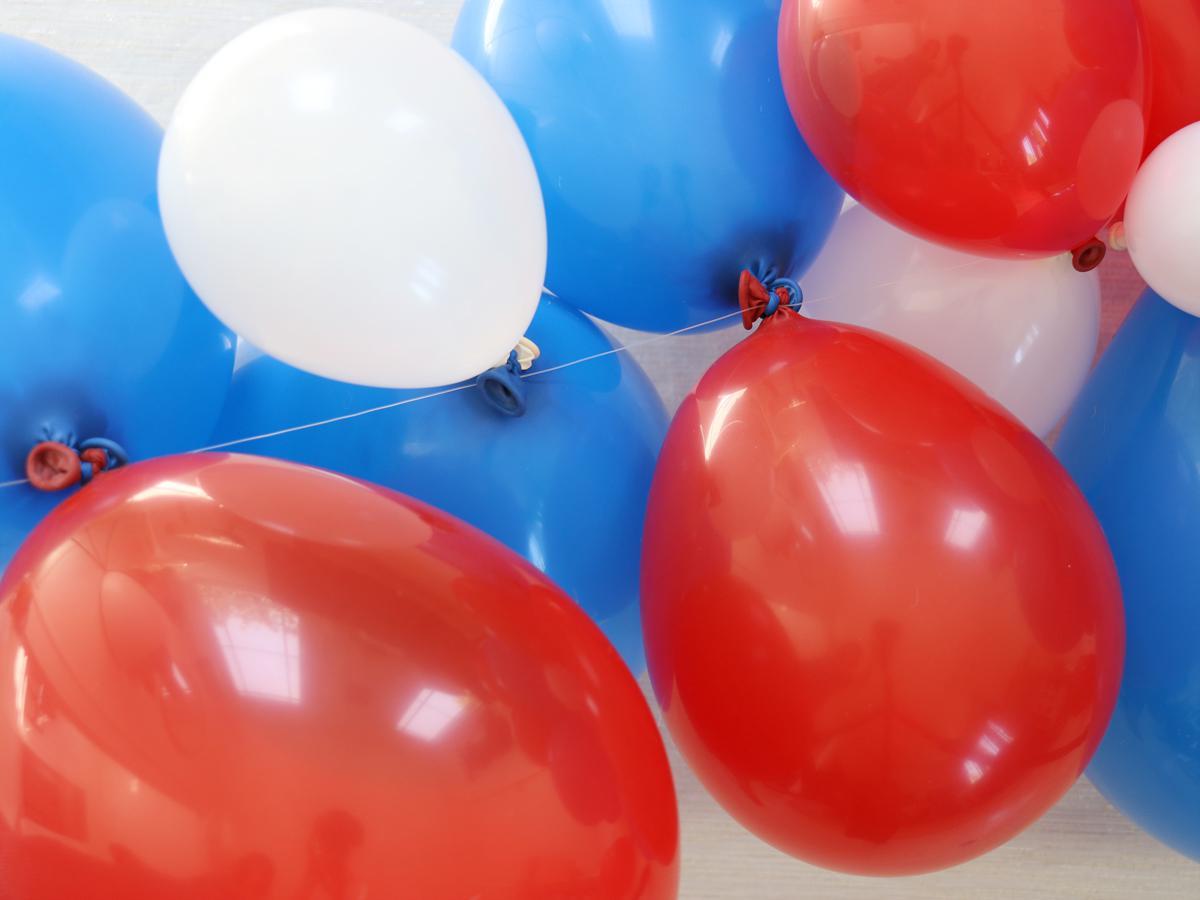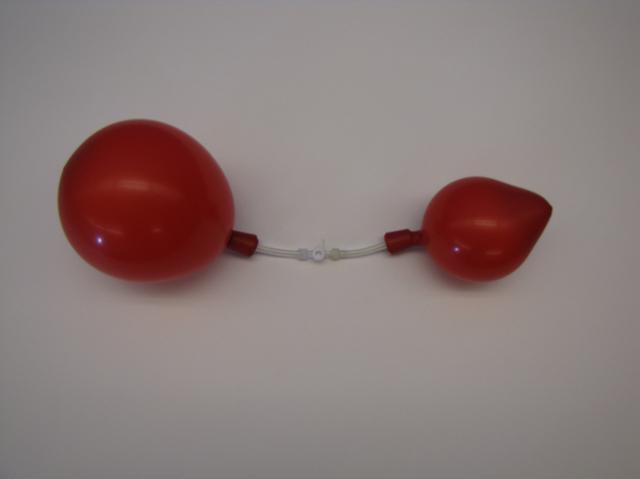The first image is the image on the left, the second image is the image on the right. For the images displayed, is the sentence "The left image contains at least two red balloons." factually correct? Answer yes or no. Yes. The first image is the image on the left, the second image is the image on the right. Given the left and right images, does the statement "An image shows exactly two balloons of different colors, posed horizontally side-by-side." hold true? Answer yes or no. No. 